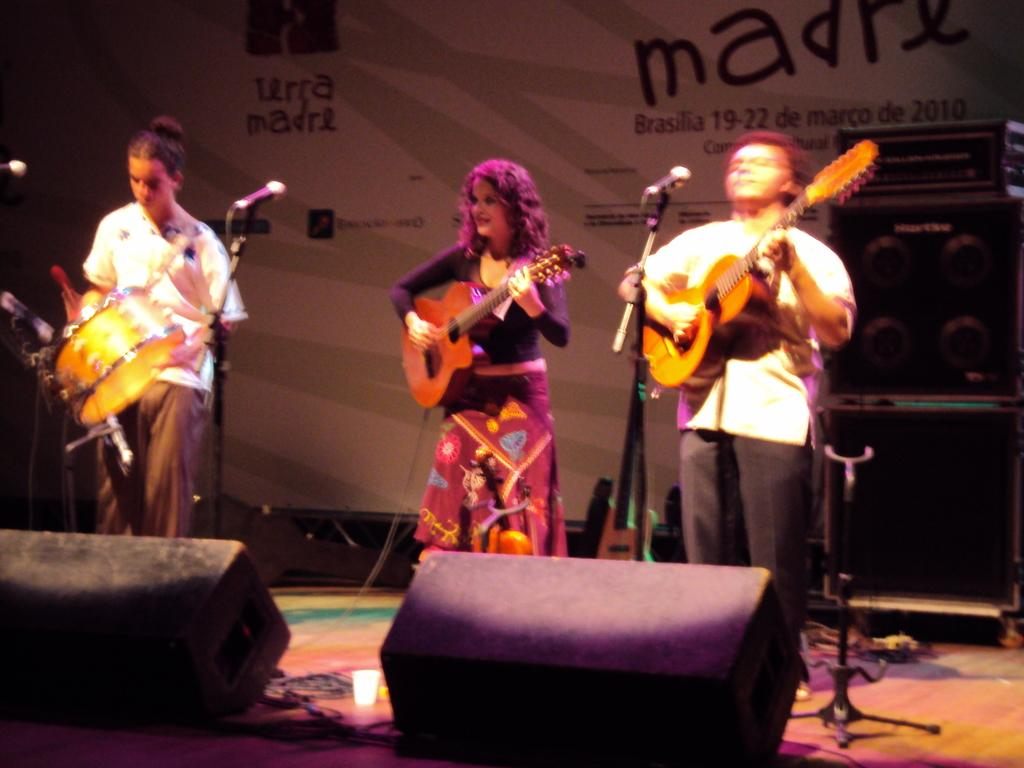How many people are in the image? There are three persons in the image. What are the persons doing in the image? The persons are standing and playing musical instruments. What is located in front of the persons? They are in front of a microphone. What can be seen in the image that might be used for illumination? There are focusing lights in the image. What type of device is present in the image? There is an electronic device in the image. What is the purpose of the sheet in the image? There is no sheet present in the image. 